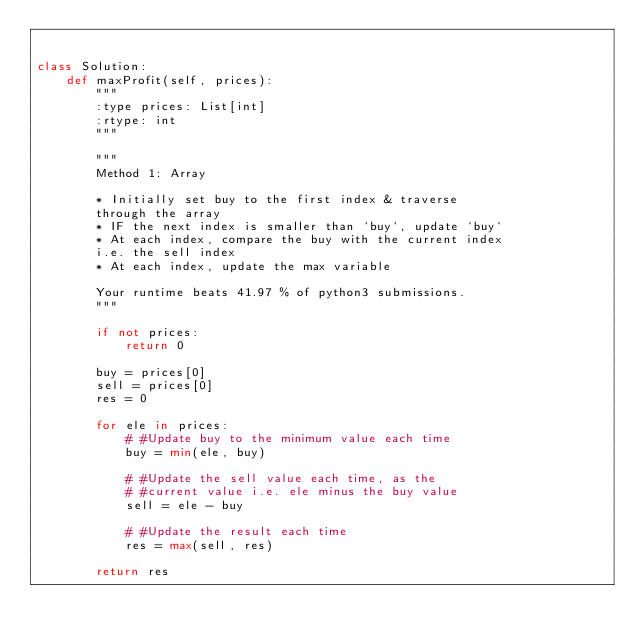<code> <loc_0><loc_0><loc_500><loc_500><_Python_>

class Solution:
    def maxProfit(self, prices):
        """
        :type prices: List[int]
        :rtype: int
        """

        """
        Method 1: Array

        * Initially set buy to the first index & traverse
        through the array
        * IF the next index is smaller than `buy`, update `buy`
        * At each index, compare the buy with the current index
        i.e. the sell index
        * At each index, update the max variable

        Your runtime beats 41.97 % of python3 submissions.
        """

        if not prices:
            return 0

        buy = prices[0]
        sell = prices[0]
        res = 0

        for ele in prices:
            # #Update buy to the minimum value each time
            buy = min(ele, buy)

            # #Update the sell value each time, as the
            # #current value i.e. ele minus the buy value
            sell = ele - buy

            # #Update the result each time
            res = max(sell, res)

        return res


</code> 